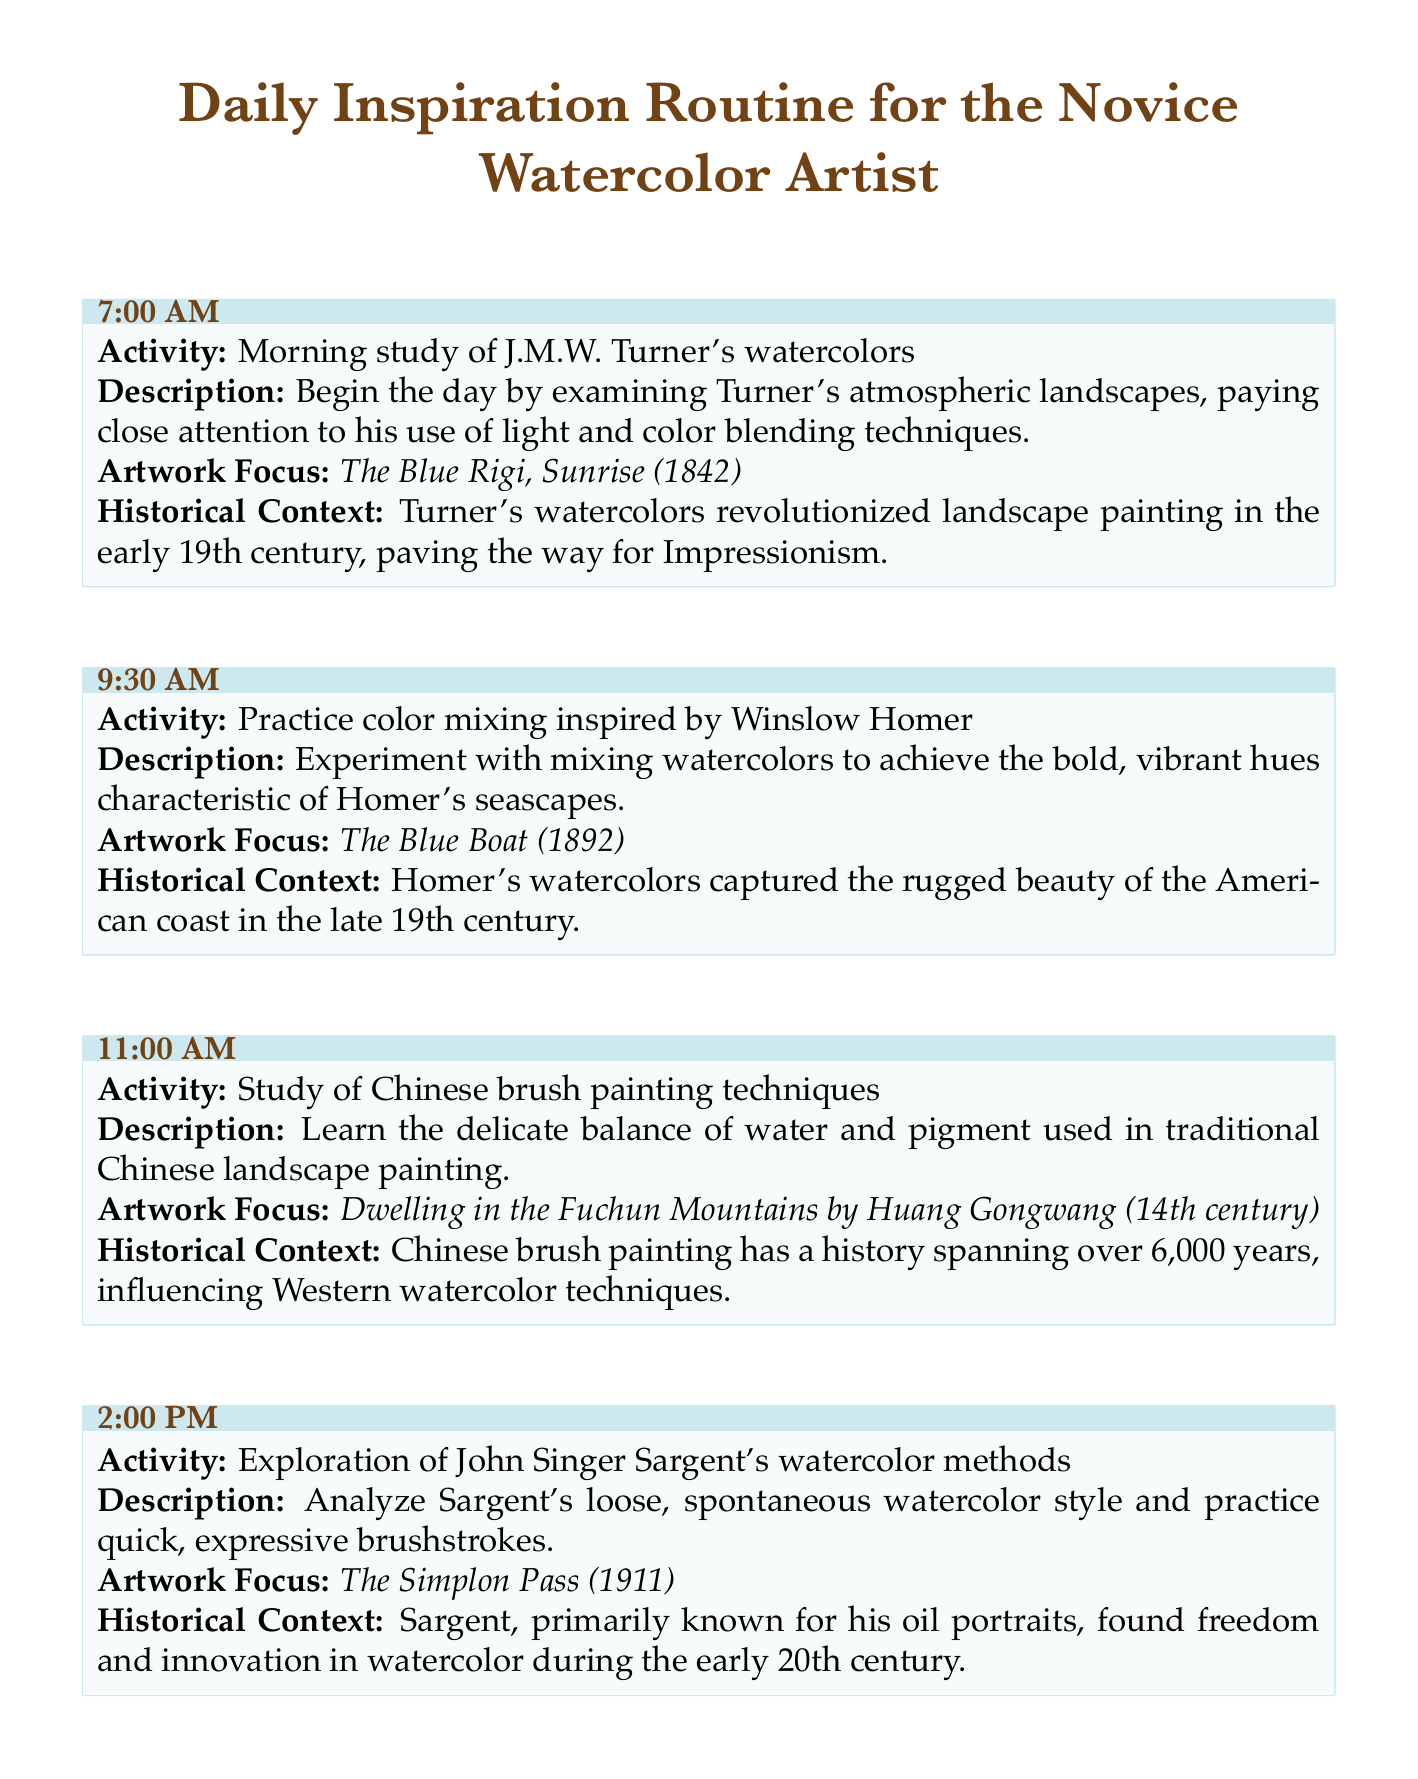What time does the morning study of J.M.W. Turner's watercolors start? The schedule states the morning study begins at 7:00 AM.
Answer: 7:00 AM Which artwork is the focus of the 11:00 AM study session? The 11:00 AM session focuses on "Dwelling in the Fuchun Mountains by Huang Gongwang."
Answer: Dwelling in the Fuchun Mountains by Huang Gongwang What is the historical context of Winslow Homer's watercolors? The document mentions Homer's watercolors captured the rugged beauty of the American coast in the late 19th century.
Answer: The rugged beauty of the American coast in the late 19th century How many activities are scheduled between 7:00 AM and 4:30 PM? There are four activities scheduled in the morning and afternoon segments leading up to 4:30 PM.
Answer: Four What painting techniques are studied at 2:00 PM? The study at 2:00 PM involves analyzing John Singer Sargent's watercolor methods.
Answer: John Singer Sargent's watercolor methods Which artist's work is associated with the evening reflection activity? The evening reflection activity is associated with William Blake's watercolor paintings.
Answer: William Blake What is the primary focus of the 4:30 PM activity? The 4:30 PM activity is focused on studying botanical illustrations by Maria Sibylla Merian.
Answer: Botanical illustrations by Maria Sibylla Merian What is a unique aspect of J.M.W. Turner's watercolors mentioned in the schedule? The schedule indicates that Turner's watercolors revolutionized landscape painting in the early 19th century.
Answer: Revolutionized landscape painting in the early 19th century 